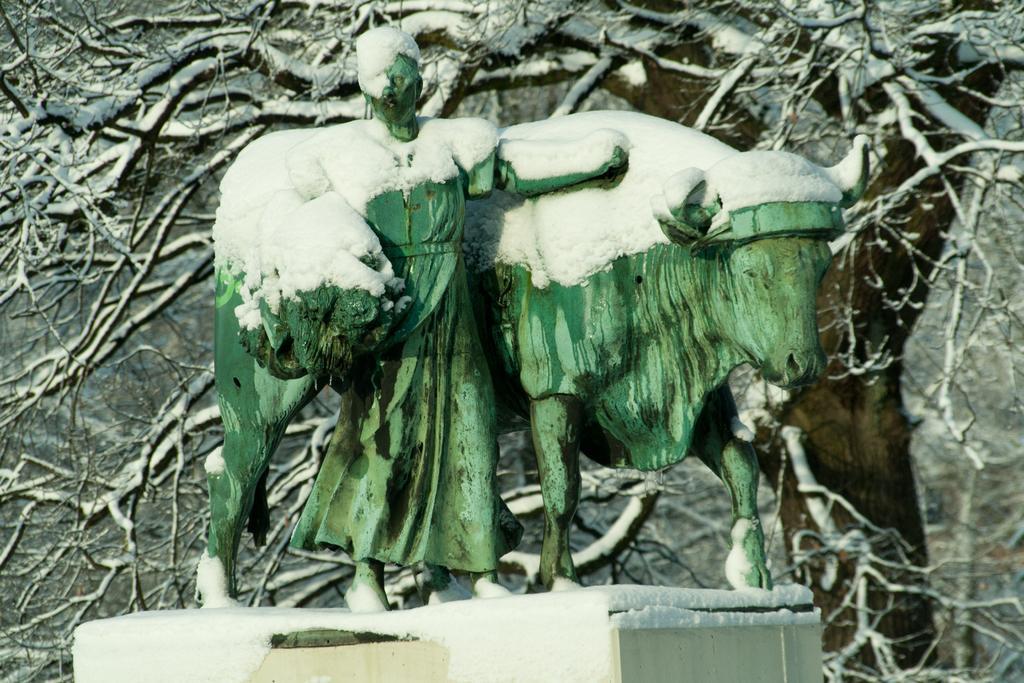Could you give a brief overview of what you see in this image? In this image we can see statue of a person and an animal on the pedestal. Here we can see snow. In the background we can see branches covered with snow. 